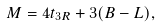Convert formula to latex. <formula><loc_0><loc_0><loc_500><loc_500>M = 4 t _ { 3 R } + 3 ( B - L ) ,</formula> 